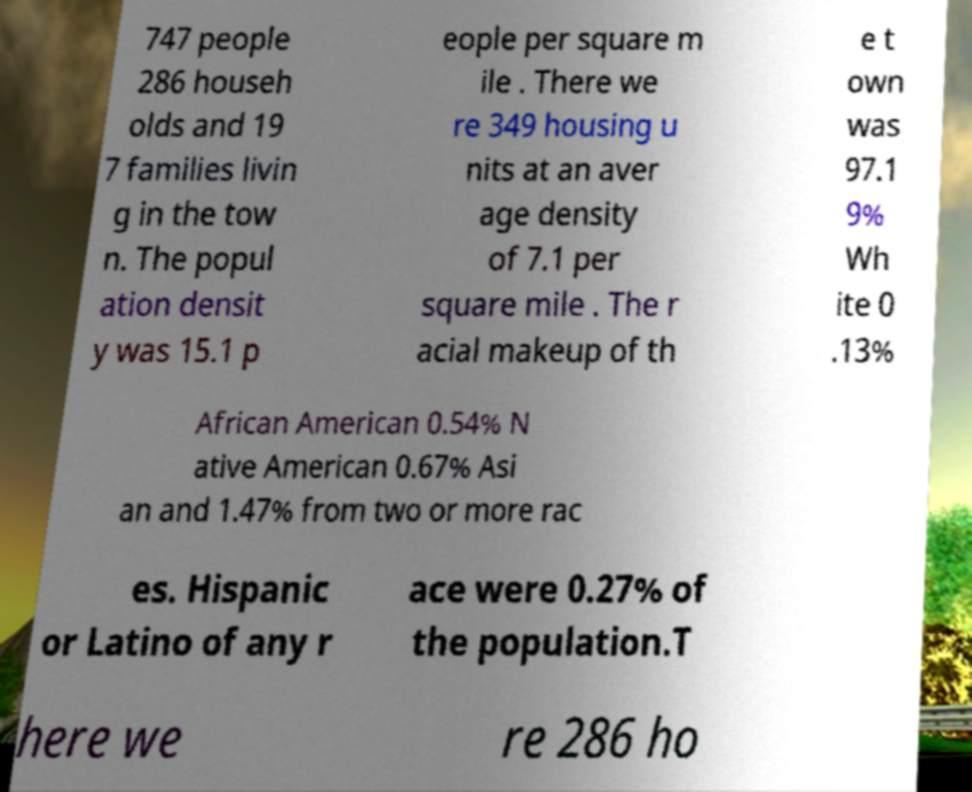I need the written content from this picture converted into text. Can you do that? 747 people 286 househ olds and 19 7 families livin g in the tow n. The popul ation densit y was 15.1 p eople per square m ile . There we re 349 housing u nits at an aver age density of 7.1 per square mile . The r acial makeup of th e t own was 97.1 9% Wh ite 0 .13% African American 0.54% N ative American 0.67% Asi an and 1.47% from two or more rac es. Hispanic or Latino of any r ace were 0.27% of the population.T here we re 286 ho 